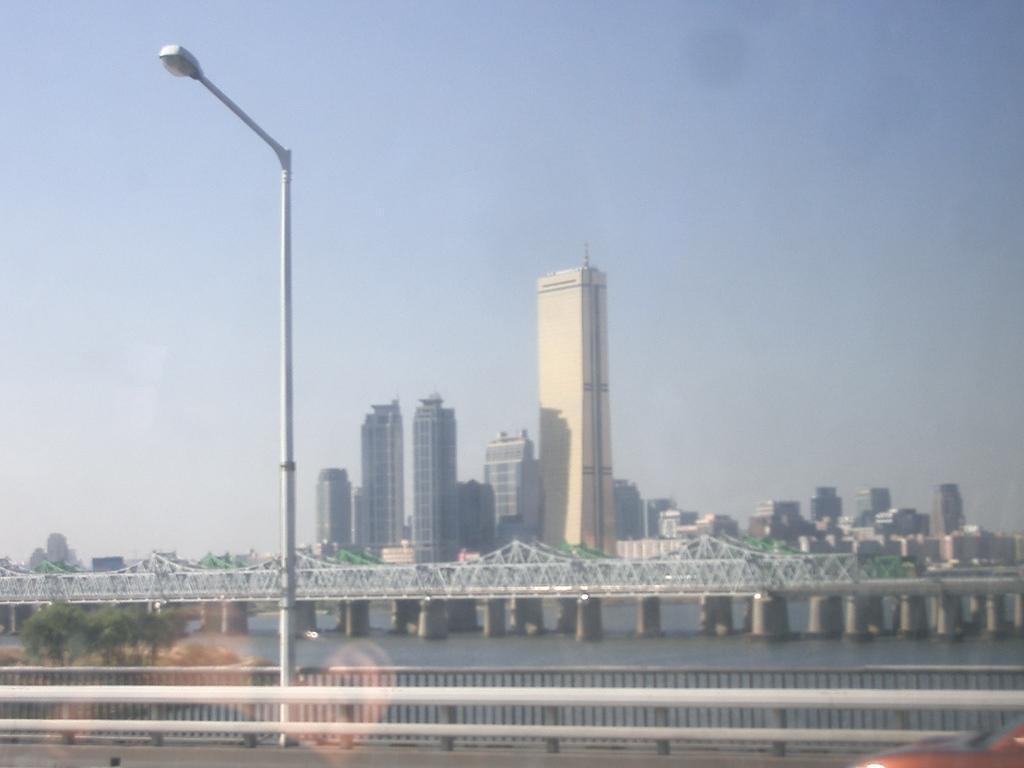Describe this image in one or two sentences. We can see light on pole,behind the pole we can see fence. We can see trees and water. In the background we can see bridge,buildings and sky. 